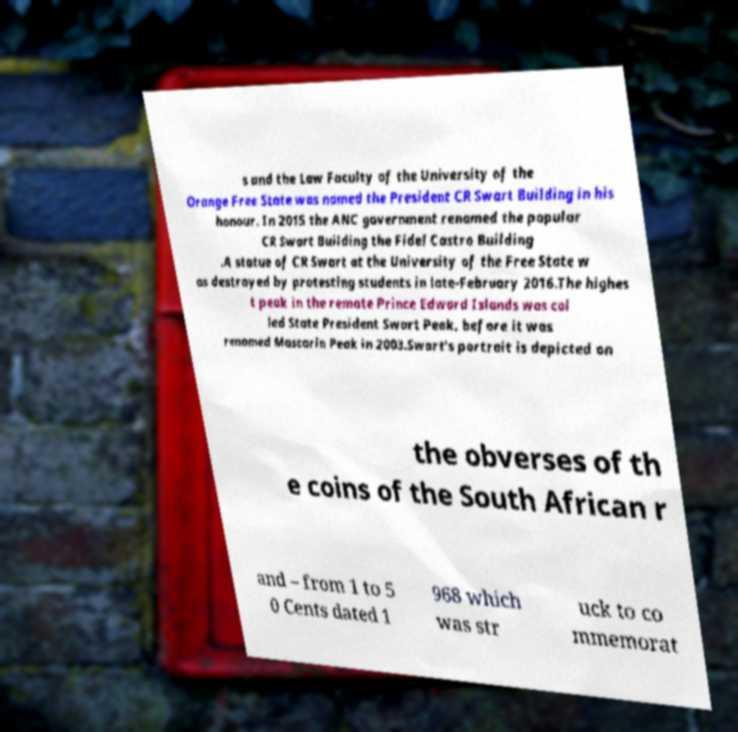Please read and relay the text visible in this image. What does it say? s and the Law Faculty of the University of the Orange Free State was named the President CR Swart Building in his honour. In 2015 the ANC government renamed the popular CR Swart Building the Fidel Castro Building .A statue of CR Swart at the University of the Free State w as destroyed by protesting students in late-February 2016.The highes t peak in the remote Prince Edward Islands was cal led State President Swart Peak, before it was renamed Mascarin Peak in 2003.Swart's portrait is depicted on the obverses of th e coins of the South African r and – from 1 to 5 0 Cents dated 1 968 which was str uck to co mmemorat 